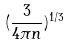<formula> <loc_0><loc_0><loc_500><loc_500>( \frac { 3 } { 4 \pi n } ) ^ { 1 / 3 }</formula> 